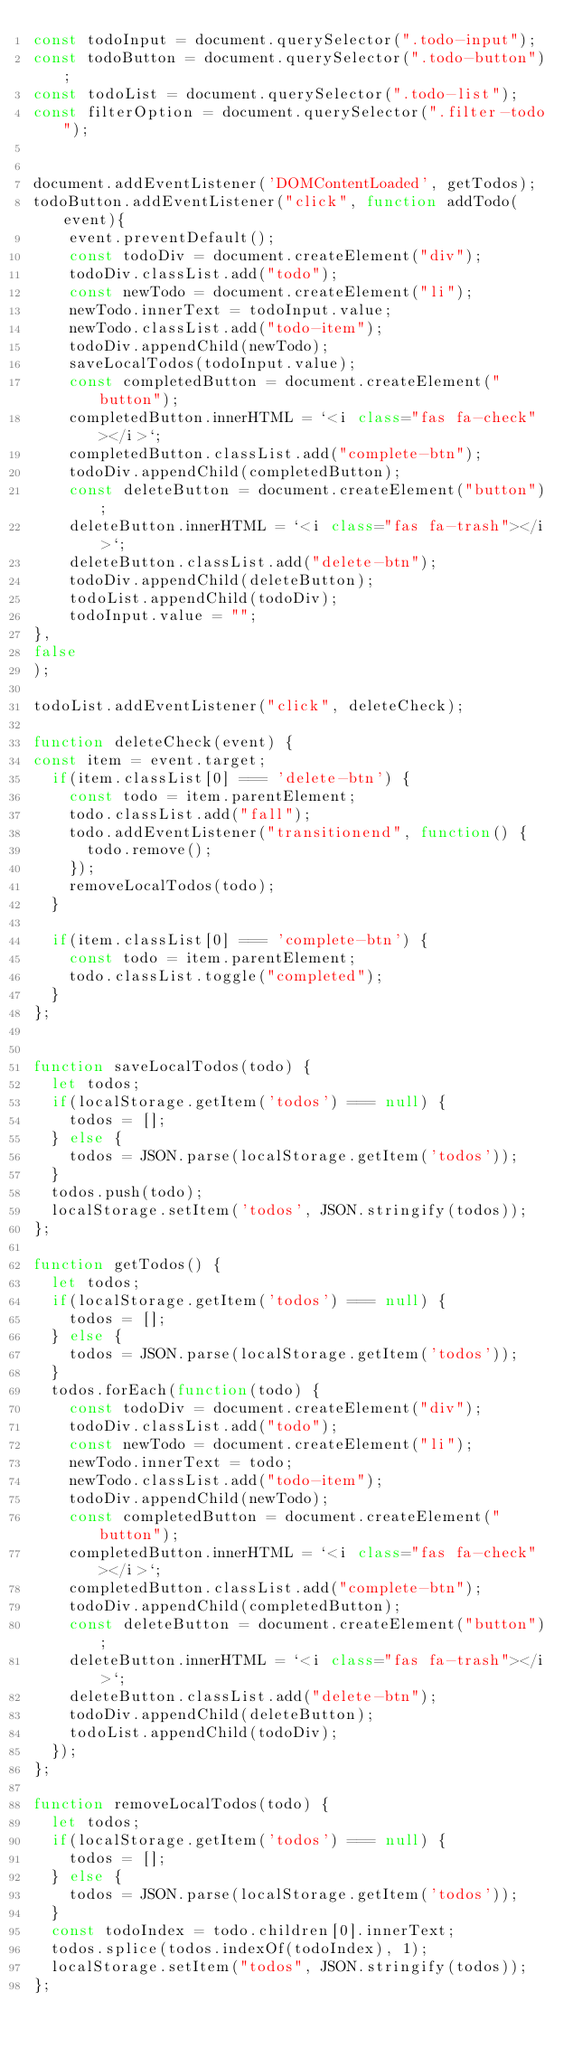Convert code to text. <code><loc_0><loc_0><loc_500><loc_500><_JavaScript_>const todoInput = document.querySelector(".todo-input");
const todoButton = document.querySelector(".todo-button");
const todoList = document.querySelector(".todo-list");
const filterOption = document.querySelector(".filter-todo");


document.addEventListener('DOMContentLoaded', getTodos);
todoButton.addEventListener("click", function addTodo(event){
    event.preventDefault();
    const todoDiv = document.createElement("div");
    todoDiv.classList.add("todo");
    const newTodo = document.createElement("li");
    newTodo.innerText = todoInput.value;
    newTodo.classList.add("todo-item");
    todoDiv.appendChild(newTodo);
    saveLocalTodos(todoInput.value);
    const completedButton = document.createElement("button");
    completedButton.innerHTML = `<i class="fas fa-check"></i>`;
    completedButton.classList.add("complete-btn");
    todoDiv.appendChild(completedButton);
    const deleteButton = document.createElement("button");
    deleteButton.innerHTML = `<i class="fas fa-trash"></i>`;
    deleteButton.classList.add("delete-btn");
    todoDiv.appendChild(deleteButton);
    todoList.appendChild(todoDiv);
    todoInput.value = "";
},
false
);

todoList.addEventListener("click", deleteCheck);

function deleteCheck(event) {
const item = event.target;
  if(item.classList[0] === 'delete-btn') {
    const todo = item.parentElement;
    todo.classList.add("fall");
    todo.addEventListener("transitionend", function() {
      todo.remove();
    });  
    removeLocalTodos(todo); 
  }

  if(item.classList[0] === 'complete-btn') {
    const todo = item.parentElement;
    todo.classList.toggle("completed");
  }
};


function saveLocalTodos(todo) {
  let todos;
  if(localStorage.getItem('todos') === null) {
    todos = [];
  } else {
    todos = JSON.parse(localStorage.getItem('todos'));
  }
  todos.push(todo);
  localStorage.setItem('todos', JSON.stringify(todos));
};

function getTodos() {
  let todos;
  if(localStorage.getItem('todos') === null) {
    todos = [];
  } else {
    todos = JSON.parse(localStorage.getItem('todos'));
  }
  todos.forEach(function(todo) {
    const todoDiv = document.createElement("div");
    todoDiv.classList.add("todo");
    const newTodo = document.createElement("li");
    newTodo.innerText = todo;
    newTodo.classList.add("todo-item");
    todoDiv.appendChild(newTodo);
    const completedButton = document.createElement("button");
    completedButton.innerHTML = `<i class="fas fa-check"></i>`;
    completedButton.classList.add("complete-btn");
    todoDiv.appendChild(completedButton);
    const deleteButton = document.createElement("button");
    deleteButton.innerHTML = `<i class="fas fa-trash"></i>`;
    deleteButton.classList.add("delete-btn");
    todoDiv.appendChild(deleteButton);
    todoList.appendChild(todoDiv);
  });
};

function removeLocalTodos(todo) {
  let todos;
  if(localStorage.getItem('todos') === null) {
    todos = [];
  } else {
    todos = JSON.parse(localStorage.getItem('todos'));
  }
  const todoIndex = todo.children[0].innerText;
  todos.splice(todos.indexOf(todoIndex), 1);
  localStorage.setItem("todos", JSON.stringify(todos));
};
</code> 